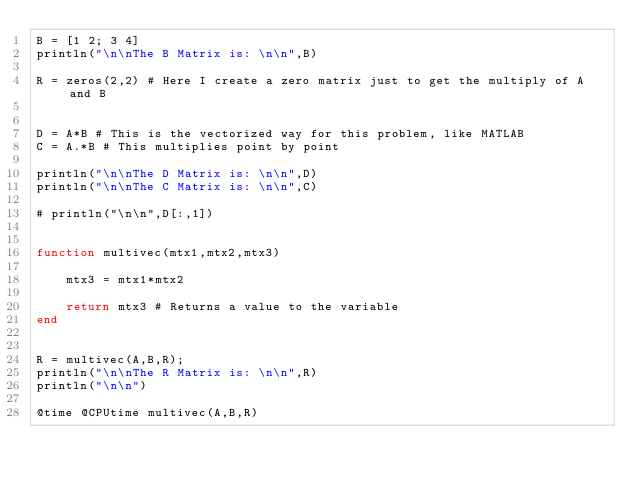Convert code to text. <code><loc_0><loc_0><loc_500><loc_500><_Julia_>B = [1 2; 3 4]
println("\n\nThe B Matrix is: \n\n",B)

R = zeros(2,2) # Here I create a zero matrix just to get the multiply of A and B


D = A*B # This is the vectorized way for this problem, like MATLAB
C = A.*B # This multiplies point by point

println("\n\nThe D Matrix is: \n\n",D)
println("\n\nThe C Matrix is: \n\n",C)

# println("\n\n",D[:,1])


function multivec(mtx1,mtx2,mtx3)

    mtx3 = mtx1*mtx2

    return mtx3 # Returns a value to the variable
end


R = multivec(A,B,R);
println("\n\nThe R Matrix is: \n\n",R)
println("\n\n")

@time @CPUtime multivec(A,B,R)</code> 